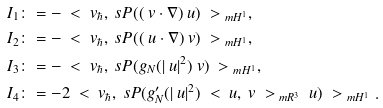Convert formula to latex. <formula><loc_0><loc_0><loc_500><loc_500>I _ { 1 } & \colon = - \ < \ v _ { \hbar } , \ s P ( ( \ v \cdot \nabla ) \ u ) \ > _ { \ m H ^ { 1 } } , \\ I _ { 2 } & \colon = - \ < \ v _ { \hbar } , \ s P ( ( \ u \cdot \nabla ) \ v ) \ > _ { \ m H ^ { 1 } } , \\ I _ { 3 } & \colon = - \ < \ v _ { \hbar } , \ s P ( g _ { N } ( | \ u | ^ { 2 } ) \ v ) \ > _ { \ m H ^ { 1 } } , \\ I _ { 4 } & \colon = - 2 \ < \ v _ { \hbar } , \ s P ( g ^ { \prime } _ { N } ( | \ u | ^ { 2 } ) \ < \ u , \ v \ > _ { \ m R ^ { 3 } } \ u ) \ > _ { \ m H ^ { 1 } } .</formula> 